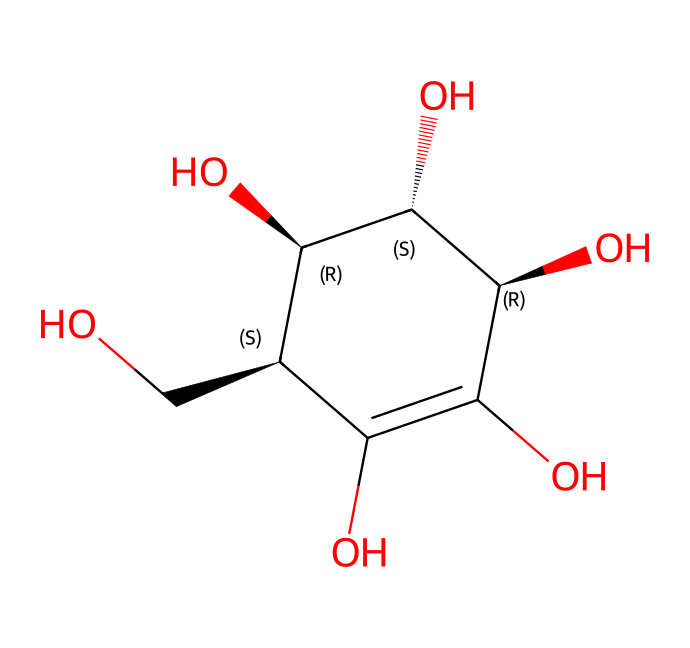How many carbon atoms are in the structure of vitamin C? The SMILES notation shows a molecular structure where 'C' represents carbon atoms. Counting the 'C' symbols in the structure gives a total of six carbon atoms.
Answer: six What is the molecular formula of vitamin C? To derive the molecular formula, we determine the total number of each type of atom in the structure: there are six carbon (C), eight hydrogen (H), and six oxygen (O) atoms. Therefore, the molecular formula is C6H8O6.
Answer: C6H8O6 Which functional groups are present in vitamin C? Analyzing the structure reveals hydroxyl (–OH) groups and a ketone (C=O) group. The presence of multiple hydroxy groups suggests it is a polyol compound. This information identifies the main functional groups in vitamin C.
Answer: hydroxyl and ketone How many hydroxyl groups are present in vitamin C? By inspecting the structure for hydroxyl (–OH) groups, we can count four instances of hydroxyl groups attached to carbon atoms.
Answer: four Does vitamin C contain any double bonds? The presence of the 'C=C' in the SMILES structure indicates there is at least one double bond between carbon atoms. As we interpret the structure, we can confirm the existence of a double bond in the compound.
Answer: yes What type of compound is vitamin C? Vitamin C is known as an essential nutrient and can be classified as a vitamin and an antioxidant based on its structural properties and biological functions.
Answer: antioxidant Which stereocenters are present in vitamin C? Examining the stereochemical aspects of the structure, we identify four chiral centers as indicated by the '@' symbols in the SMILES notation, which correspond to carbon atoms with four different groups attached.
Answer: four 